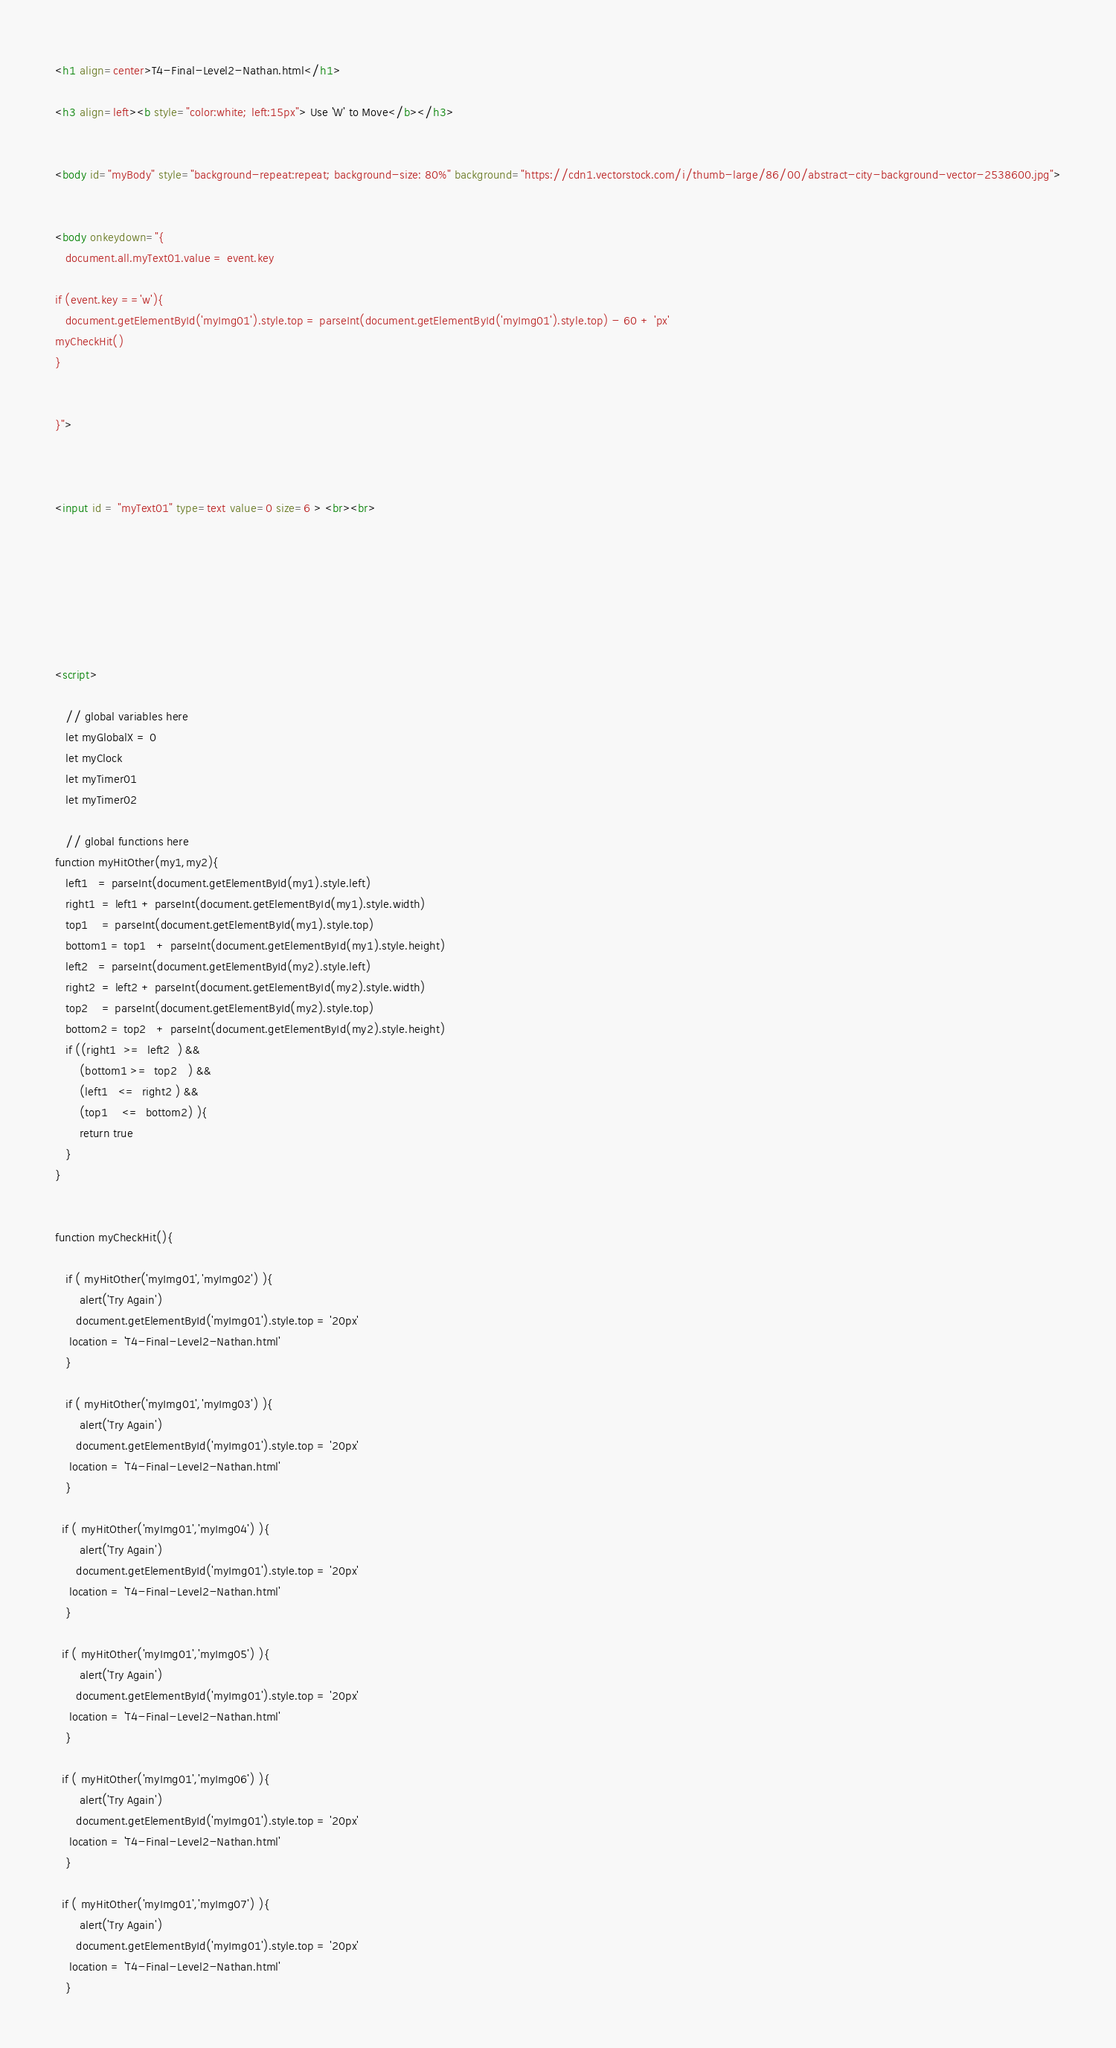Convert code to text. <code><loc_0><loc_0><loc_500><loc_500><_HTML_><h1 align=center>T4-Final-Level2-Nathan.html</h1>

<h3 align=left><b style="color:white; left:15px"> Use 'W' to Move</b></h3>


<body id="myBody" style="background-repeat:repeat; background-size: 80%" background="https://cdn1.vectorstock.com/i/thumb-large/86/00/abstract-city-background-vector-2538600.jpg">


<body onkeydown="{
   document.all.myText01.value = event.key

if (event.key =='w'){
   document.getElementById('myImg01').style.top = parseInt(document.getElementById('myImg01').style.top) - 60 + 'px'
myCheckHit()
}


}">



<input id = "myText01" type=text value=0 size=6 > <br><br>







<script>

   // global variables here
   let myGlobalX = 0
   let myClock
   let myTimer01
   let myTimer02

   // global functions here
function myHitOther(my1,my2){
   left1   = parseInt(document.getElementById(my1).style.left)
   right1  = left1 + parseInt(document.getElementById(my1).style.width)
   top1    = parseInt(document.getElementById(my1).style.top)   
   bottom1 = top1   + parseInt(document.getElementById(my1).style.height)
   left2   = parseInt(document.getElementById(my2).style.left)
   right2  = left2 + parseInt(document.getElementById(my2).style.width)
   top2    = parseInt(document.getElementById(my2).style.top)   
   bottom2 = top2   + parseInt(document.getElementById(my2).style.height)
   if ((right1  >=  left2  ) &&      	   
       (bottom1 >=  top2   ) &&
       (left1   <=  right2 ) &&
       (top1    <=  bottom2) ){
       return true
   }
}


function myCheckHit(){

   if ( myHitOther('myImg01','myImg02') ){
       alert('Try Again')
      document.getElementById('myImg01').style.top = '20px'
    location = 'T4-Final-Level2-Nathan.html'
   }

   if ( myHitOther('myImg01','myImg03') ){
       alert('Try Again')
      document.getElementById('myImg01').style.top = '20px'
    location = 'T4-Final-Level2-Nathan.html'
   }

  if ( myHitOther('myImg01','myImg04') ){
       alert('Try Again')
      document.getElementById('myImg01').style.top = '20px'
    location = 'T4-Final-Level2-Nathan.html'
   }

  if ( myHitOther('myImg01','myImg05') ){
       alert('Try Again')
      document.getElementById('myImg01').style.top = '20px'
    location = 'T4-Final-Level2-Nathan.html'
   }

  if ( myHitOther('myImg01','myImg06') ){
       alert('Try Again')
      document.getElementById('myImg01').style.top = '20px'
    location = 'T4-Final-Level2-Nathan.html'
   }

  if ( myHitOther('myImg01','myImg07') ){
       alert('Try Again')
      document.getElementById('myImg01').style.top = '20px'
    location = 'T4-Final-Level2-Nathan.html'
   }
</code> 